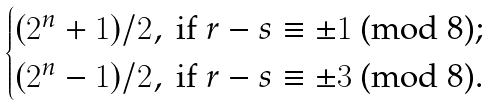<formula> <loc_0><loc_0><loc_500><loc_500>\begin{cases} ( 2 ^ { n } + 1 ) / 2 , \text {  if $r-s \equiv \pm 1$ (mod 8);} \\ ( 2 ^ { n } - 1 ) / 2 , \text {  if $r-s \equiv \pm 3$ (mod 8).} \end{cases}</formula> 